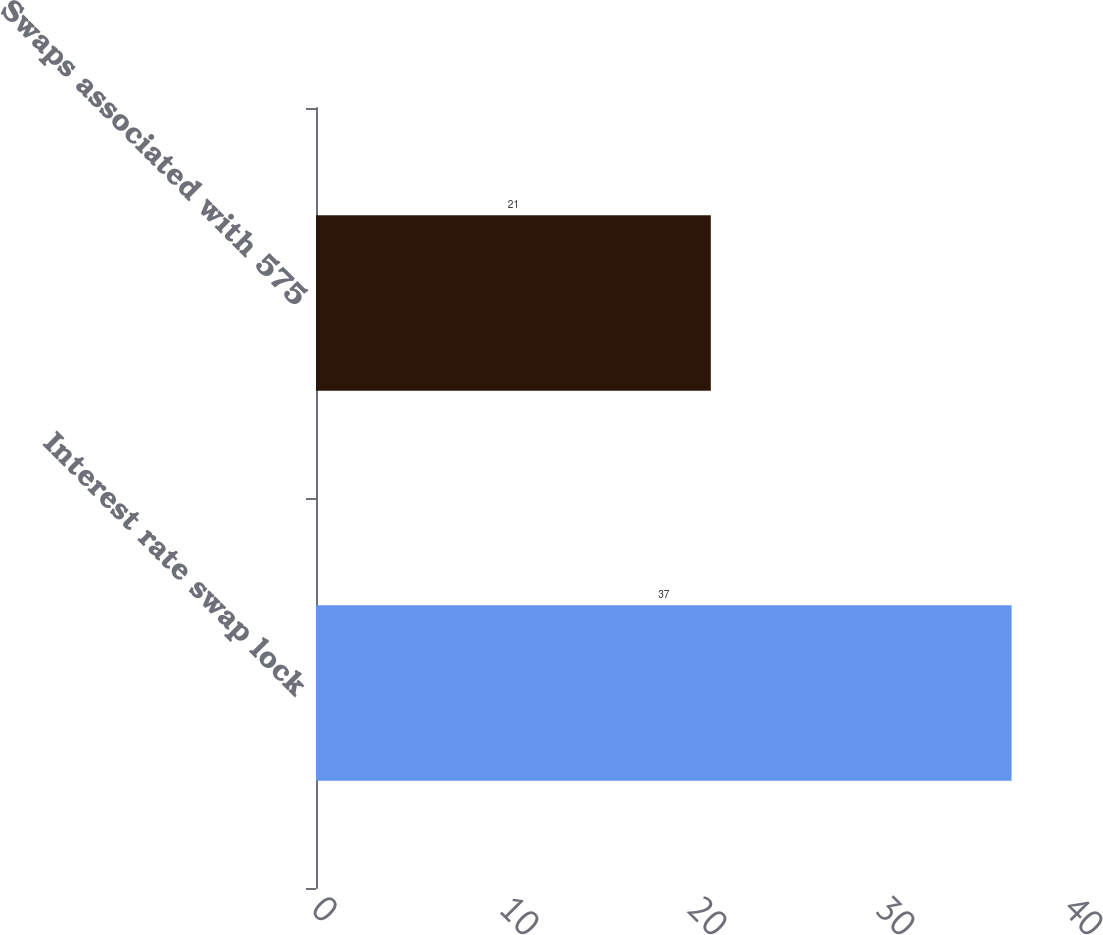Convert chart to OTSL. <chart><loc_0><loc_0><loc_500><loc_500><bar_chart><fcel>Interest rate swap lock<fcel>Swaps associated with 575<nl><fcel>37<fcel>21<nl></chart> 